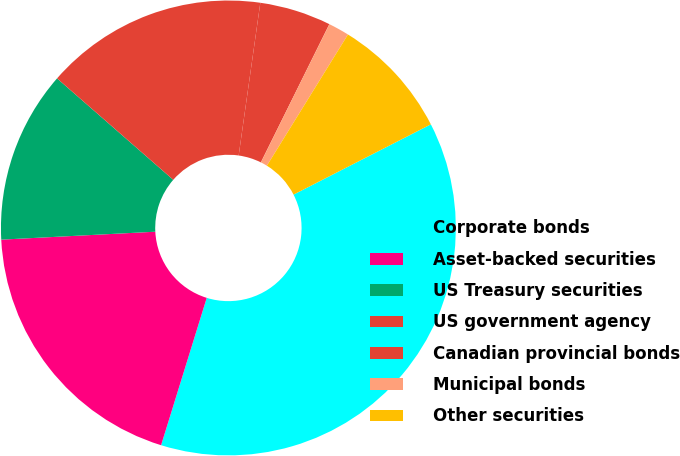<chart> <loc_0><loc_0><loc_500><loc_500><pie_chart><fcel>Corporate bonds<fcel>Asset-backed securities<fcel>US Treasury securities<fcel>US government agency<fcel>Canadian provincial bonds<fcel>Municipal bonds<fcel>Other securities<nl><fcel>37.31%<fcel>19.4%<fcel>12.24%<fcel>15.82%<fcel>5.08%<fcel>1.49%<fcel>8.66%<nl></chart> 